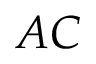<formula> <loc_0><loc_0><loc_500><loc_500>A C</formula> 